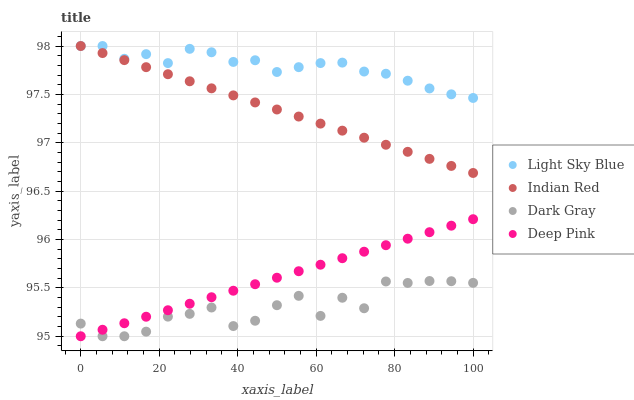Does Dark Gray have the minimum area under the curve?
Answer yes or no. Yes. Does Light Sky Blue have the maximum area under the curve?
Answer yes or no. Yes. Does Indian Red have the minimum area under the curve?
Answer yes or no. No. Does Indian Red have the maximum area under the curve?
Answer yes or no. No. Is Deep Pink the smoothest?
Answer yes or no. Yes. Is Dark Gray the roughest?
Answer yes or no. Yes. Is Light Sky Blue the smoothest?
Answer yes or no. No. Is Light Sky Blue the roughest?
Answer yes or no. No. Does Dark Gray have the lowest value?
Answer yes or no. Yes. Does Indian Red have the lowest value?
Answer yes or no. No. Does Indian Red have the highest value?
Answer yes or no. Yes. Does Deep Pink have the highest value?
Answer yes or no. No. Is Deep Pink less than Light Sky Blue?
Answer yes or no. Yes. Is Indian Red greater than Dark Gray?
Answer yes or no. Yes. Does Indian Red intersect Light Sky Blue?
Answer yes or no. Yes. Is Indian Red less than Light Sky Blue?
Answer yes or no. No. Is Indian Red greater than Light Sky Blue?
Answer yes or no. No. Does Deep Pink intersect Light Sky Blue?
Answer yes or no. No. 